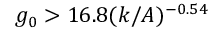<formula> <loc_0><loc_0><loc_500><loc_500>g _ { 0 } > 1 6 . 8 ( k / A ) ^ { - 0 . 5 4 }</formula> 